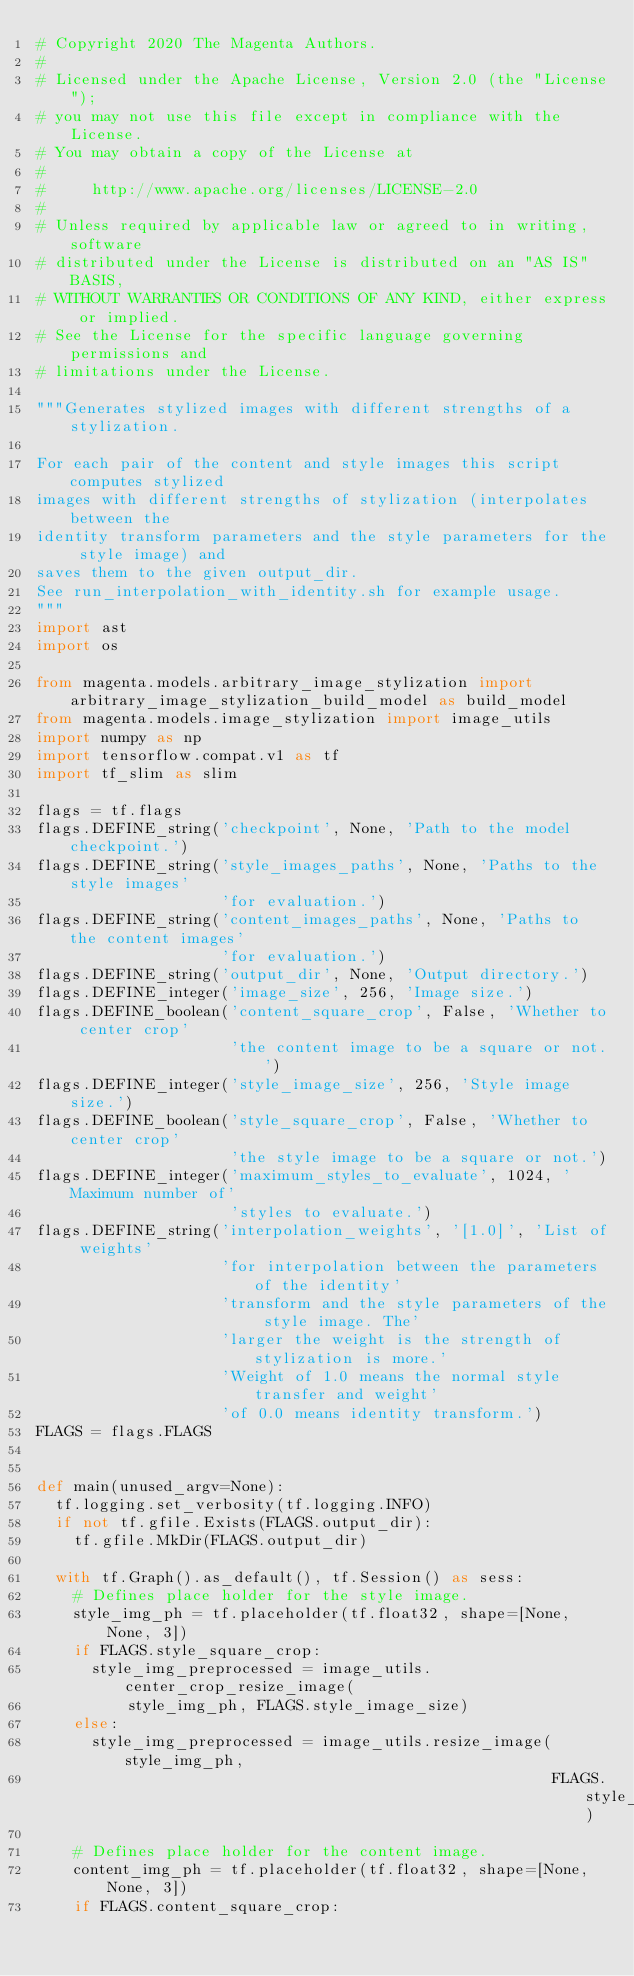Convert code to text. <code><loc_0><loc_0><loc_500><loc_500><_Python_># Copyright 2020 The Magenta Authors.
#
# Licensed under the Apache License, Version 2.0 (the "License");
# you may not use this file except in compliance with the License.
# You may obtain a copy of the License at
#
#     http://www.apache.org/licenses/LICENSE-2.0
#
# Unless required by applicable law or agreed to in writing, software
# distributed under the License is distributed on an "AS IS" BASIS,
# WITHOUT WARRANTIES OR CONDITIONS OF ANY KIND, either express or implied.
# See the License for the specific language governing permissions and
# limitations under the License.

"""Generates stylized images with different strengths of a stylization.

For each pair of the content and style images this script computes stylized
images with different strengths of stylization (interpolates between the
identity transform parameters and the style parameters for the style image) and
saves them to the given output_dir.
See run_interpolation_with_identity.sh for example usage.
"""
import ast
import os

from magenta.models.arbitrary_image_stylization import arbitrary_image_stylization_build_model as build_model
from magenta.models.image_stylization import image_utils
import numpy as np
import tensorflow.compat.v1 as tf
import tf_slim as slim

flags = tf.flags
flags.DEFINE_string('checkpoint', None, 'Path to the model checkpoint.')
flags.DEFINE_string('style_images_paths', None, 'Paths to the style images'
                    'for evaluation.')
flags.DEFINE_string('content_images_paths', None, 'Paths to the content images'
                    'for evaluation.')
flags.DEFINE_string('output_dir', None, 'Output directory.')
flags.DEFINE_integer('image_size', 256, 'Image size.')
flags.DEFINE_boolean('content_square_crop', False, 'Whether to center crop'
                     'the content image to be a square or not.')
flags.DEFINE_integer('style_image_size', 256, 'Style image size.')
flags.DEFINE_boolean('style_square_crop', False, 'Whether to center crop'
                     'the style image to be a square or not.')
flags.DEFINE_integer('maximum_styles_to_evaluate', 1024, 'Maximum number of'
                     'styles to evaluate.')
flags.DEFINE_string('interpolation_weights', '[1.0]', 'List of weights'
                    'for interpolation between the parameters of the identity'
                    'transform and the style parameters of the style image. The'
                    'larger the weight is the strength of stylization is more.'
                    'Weight of 1.0 means the normal style transfer and weight'
                    'of 0.0 means identity transform.')
FLAGS = flags.FLAGS


def main(unused_argv=None):
  tf.logging.set_verbosity(tf.logging.INFO)
  if not tf.gfile.Exists(FLAGS.output_dir):
    tf.gfile.MkDir(FLAGS.output_dir)

  with tf.Graph().as_default(), tf.Session() as sess:
    # Defines place holder for the style image.
    style_img_ph = tf.placeholder(tf.float32, shape=[None, None, 3])
    if FLAGS.style_square_crop:
      style_img_preprocessed = image_utils.center_crop_resize_image(
          style_img_ph, FLAGS.style_image_size)
    else:
      style_img_preprocessed = image_utils.resize_image(style_img_ph,
                                                        FLAGS.style_image_size)

    # Defines place holder for the content image.
    content_img_ph = tf.placeholder(tf.float32, shape=[None, None, 3])
    if FLAGS.content_square_crop:</code> 